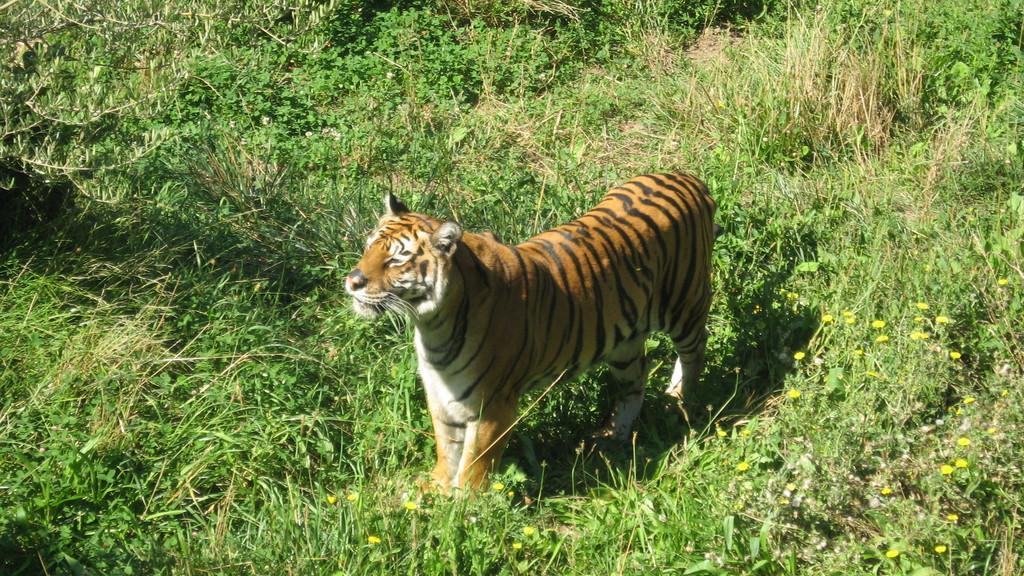In one or two sentences, can you explain what this image depicts? In this image we can see a tiger in the grass, also we can see some flowers, and plants around it. 